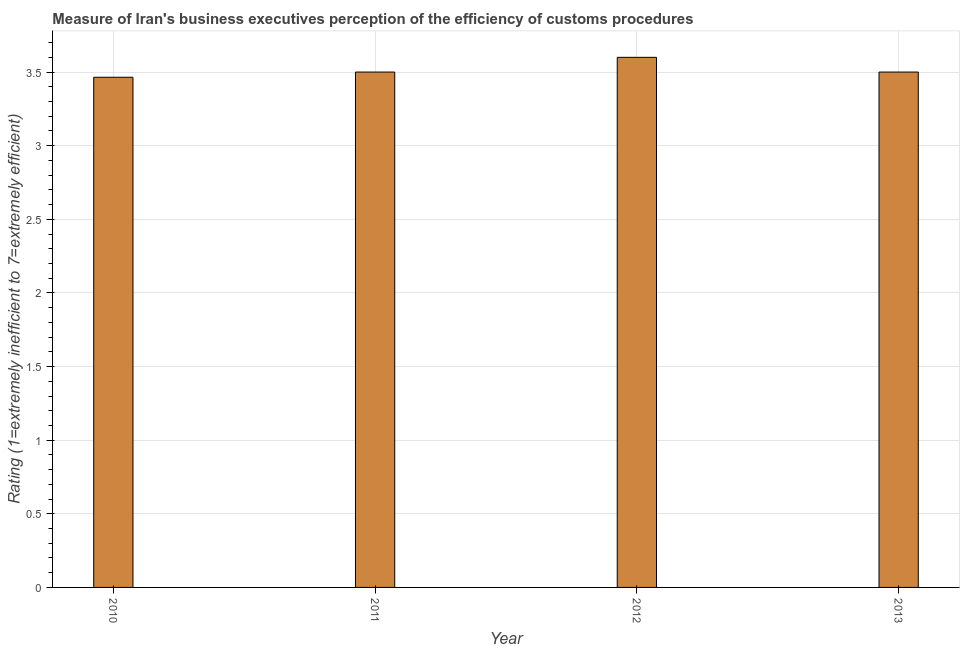Does the graph contain any zero values?
Your answer should be compact. No. What is the title of the graph?
Your response must be concise. Measure of Iran's business executives perception of the efficiency of customs procedures. What is the label or title of the X-axis?
Keep it short and to the point. Year. What is the label or title of the Y-axis?
Offer a terse response. Rating (1=extremely inefficient to 7=extremely efficient). Across all years, what is the maximum rating measuring burden of customs procedure?
Provide a succinct answer. 3.6. Across all years, what is the minimum rating measuring burden of customs procedure?
Offer a very short reply. 3.46. In which year was the rating measuring burden of customs procedure maximum?
Offer a very short reply. 2012. In which year was the rating measuring burden of customs procedure minimum?
Provide a short and direct response. 2010. What is the sum of the rating measuring burden of customs procedure?
Your answer should be compact. 14.06. What is the difference between the rating measuring burden of customs procedure in 2010 and 2012?
Make the answer very short. -0.14. What is the average rating measuring burden of customs procedure per year?
Provide a succinct answer. 3.52. In how many years, is the rating measuring burden of customs procedure greater than 3.3 ?
Your answer should be very brief. 4. Do a majority of the years between 2011 and 2010 (inclusive) have rating measuring burden of customs procedure greater than 0.1 ?
Offer a terse response. No. What is the ratio of the rating measuring burden of customs procedure in 2010 to that in 2013?
Offer a terse response. 0.99. Is the difference between the rating measuring burden of customs procedure in 2011 and 2013 greater than the difference between any two years?
Give a very brief answer. No. Is the sum of the rating measuring burden of customs procedure in 2010 and 2012 greater than the maximum rating measuring burden of customs procedure across all years?
Provide a succinct answer. Yes. What is the difference between the highest and the lowest rating measuring burden of customs procedure?
Your response must be concise. 0.14. How many bars are there?
Ensure brevity in your answer.  4. What is the difference between two consecutive major ticks on the Y-axis?
Your answer should be compact. 0.5. Are the values on the major ticks of Y-axis written in scientific E-notation?
Provide a short and direct response. No. What is the Rating (1=extremely inefficient to 7=extremely efficient) of 2010?
Give a very brief answer. 3.46. What is the Rating (1=extremely inefficient to 7=extremely efficient) of 2013?
Offer a terse response. 3.5. What is the difference between the Rating (1=extremely inefficient to 7=extremely efficient) in 2010 and 2011?
Provide a short and direct response. -0.04. What is the difference between the Rating (1=extremely inefficient to 7=extremely efficient) in 2010 and 2012?
Provide a short and direct response. -0.14. What is the difference between the Rating (1=extremely inefficient to 7=extremely efficient) in 2010 and 2013?
Your answer should be compact. -0.04. What is the difference between the Rating (1=extremely inefficient to 7=extremely efficient) in 2011 and 2012?
Your answer should be compact. -0.1. What is the difference between the Rating (1=extremely inefficient to 7=extremely efficient) in 2011 and 2013?
Provide a short and direct response. 0. What is the ratio of the Rating (1=extremely inefficient to 7=extremely efficient) in 2010 to that in 2011?
Offer a very short reply. 0.99. What is the ratio of the Rating (1=extremely inefficient to 7=extremely efficient) in 2010 to that in 2012?
Offer a very short reply. 0.96. What is the ratio of the Rating (1=extremely inefficient to 7=extremely efficient) in 2010 to that in 2013?
Provide a succinct answer. 0.99. What is the ratio of the Rating (1=extremely inefficient to 7=extremely efficient) in 2011 to that in 2012?
Your answer should be compact. 0.97. What is the ratio of the Rating (1=extremely inefficient to 7=extremely efficient) in 2011 to that in 2013?
Keep it short and to the point. 1. 